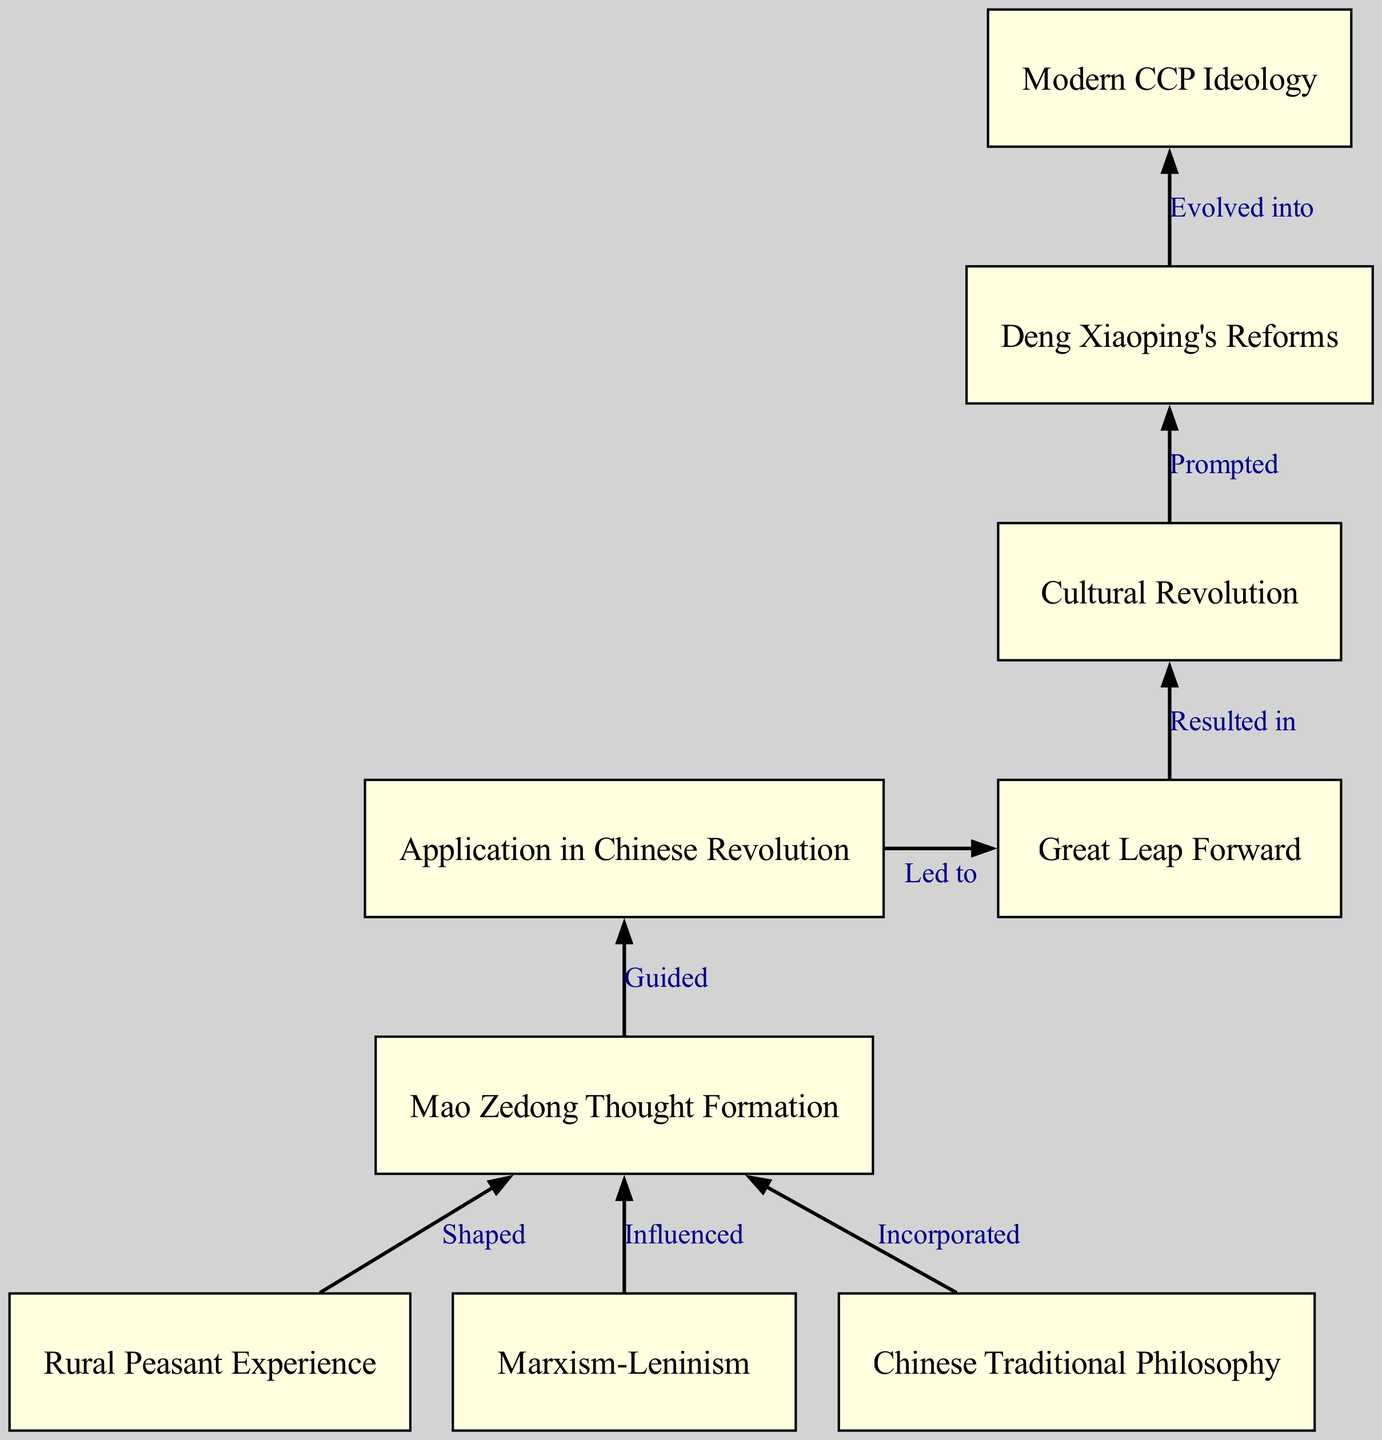What is the first factor that shaped Mao Zedong Thought? The first factor in the diagram that influenced the formation of Mao Zedong Thought is "Rural Peasant Experience". It is marked as the first node leading to the formation of Mao Zedong Thought.
Answer: Rural Peasant Experience How many nodes are present in the diagram? By counting each distinct labeled box, there are a total of nine nodes depicted in the diagram.
Answer: 9 What relationship does Marxism-Leninism have with Mao Zedong Thought? The diagram states that Marxism-Leninism "Influenced" Mao Zedong Thought, showing a direct connection from the Marxism-Leninism node to the Mao Zedong Thought node.
Answer: Influenced What event did the application of Mao Zedong Thought guide? According to the diagram, the application of Mao Zedong Thought guided the "Chinese Revolution", which is represented as the node directly succeeding Mao Zedong Thought.
Answer: Chinese Revolution What is the outcome of the Great Leap Forward according to the diagram? The diagram indicates that the Great Leap Forward "Resulted in" the Cultural Revolution, showing a sequential flow from one concept to another.
Answer: Cultural Revolution Which event prompted Deng Xiaoping's reforms? The diagram clearly represents that the Cultural Revolution "Prompted" Deng Xiaoping's reforms, connecting these two significant historical events.
Answer: Prompted What evolved into Modern CCP Ideology? As per the diagram, Deng Xiaoping's Reforms "Evolved into" Modern CCP Ideology, marking the progression from reformative actions to evolved ideological frameworks.
Answer: Evolved into Which three factors contributed to the formation of Mao Zedong Thought? The diagram shows three factors that contributed to Mao Zedong Thought, which are "Rural Peasant Experience", "Marxism-Leninism", and "Chinese Traditional Philosophy".
Answer: Rural Peasant Experience, Marxism-Leninism, Chinese Traditional Philosophy How is the relationship between the Cultural Revolution and the Great Leap Forward described? In the diagram, the flow indicates that the Great Leap Forward "Resulted in" the Cultural Revolution, illustrating a cause-and-effect relationship between these two events.
Answer: Resulted in 